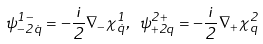<formula> <loc_0><loc_0><loc_500><loc_500>\psi ^ { 1 - } _ { - 2 \dot { q } } = - \frac { i } { 2 } \nabla _ { - } \chi ^ { 1 } _ { \dot { q } } , \ \psi ^ { 2 + } _ { + 2 q } = - \frac { i } { 2 } \nabla _ { + } \chi ^ { 2 } _ { q }</formula> 